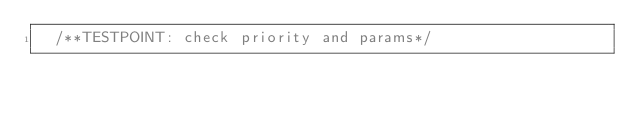Convert code to text. <code><loc_0><loc_0><loc_500><loc_500><_C_>	/**TESTPOINT: check priority and params*/</code> 